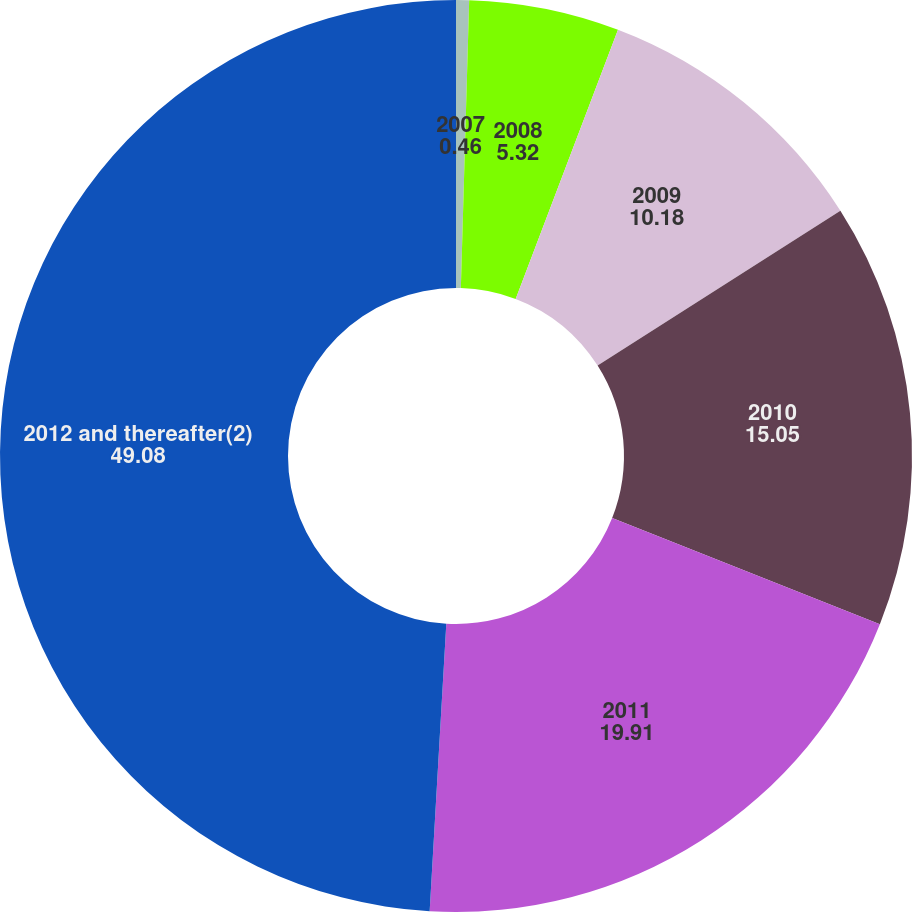Convert chart. <chart><loc_0><loc_0><loc_500><loc_500><pie_chart><fcel>2007<fcel>2008<fcel>2009<fcel>2010<fcel>2011<fcel>2012 and thereafter(2)<nl><fcel>0.46%<fcel>5.32%<fcel>10.18%<fcel>15.05%<fcel>19.91%<fcel>49.08%<nl></chart> 